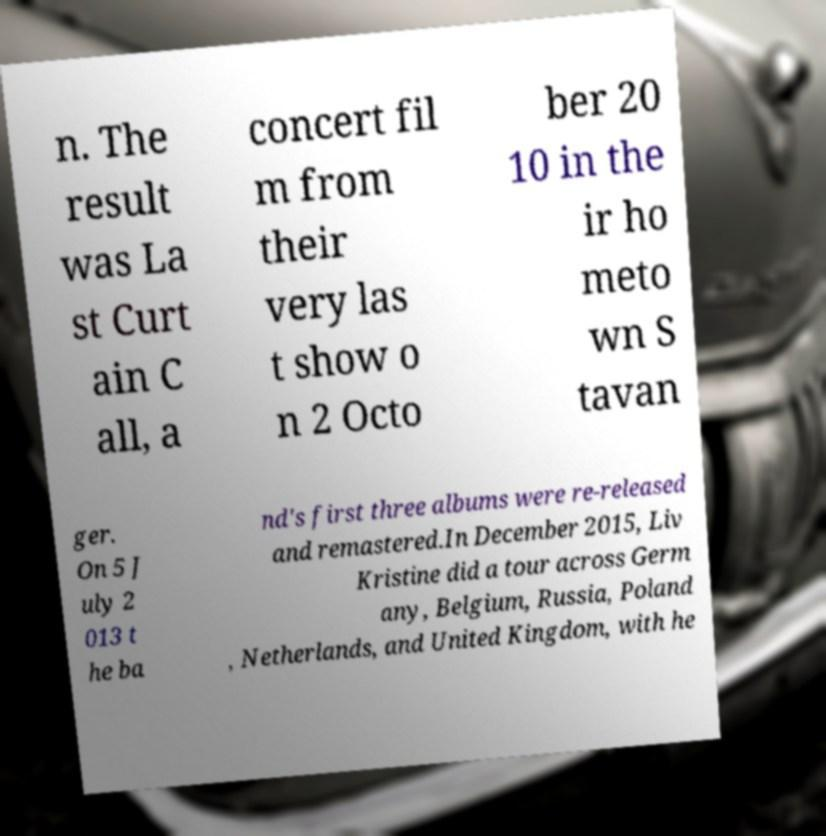There's text embedded in this image that I need extracted. Can you transcribe it verbatim? n. The result was La st Curt ain C all, a concert fil m from their very las t show o n 2 Octo ber 20 10 in the ir ho meto wn S tavan ger. On 5 J uly 2 013 t he ba nd's first three albums were re-released and remastered.In December 2015, Liv Kristine did a tour across Germ any, Belgium, Russia, Poland , Netherlands, and United Kingdom, with he 